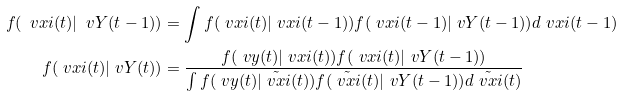Convert formula to latex. <formula><loc_0><loc_0><loc_500><loc_500>f ( \ v x i ( t ) | \ v Y ( t - 1 ) ) & = \int f ( \ v x i ( t ) | \ v x i ( t - 1 ) ) f ( \ v x i ( t - 1 ) | \ v Y ( t - 1 ) ) d \ v x i ( t - 1 ) \\ f ( \ v x i ( t ) | \ v Y ( t ) ) & = \frac { f ( \ v y ( t ) | \ v x i ( t ) ) f ( \ v x i ( t ) | \ v Y ( t - 1 ) ) } { \int f ( \ v y ( t ) | \tilde { \ v x i } ( t ) ) f ( \tilde { \ v x i } ( t ) | \ v Y ( t - 1 ) ) d \tilde { \ v x i } ( t ) }</formula> 